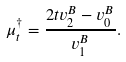<formula> <loc_0><loc_0><loc_500><loc_500>\mu _ { t } ^ { \dag } = \frac { 2 t v _ { 2 } ^ { B } - v _ { 0 } ^ { B } } { v _ { 1 } ^ { B } } .</formula> 